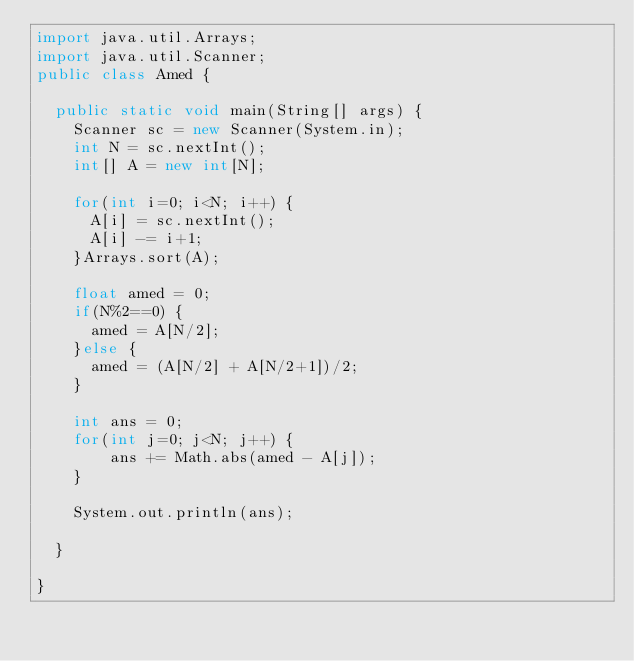<code> <loc_0><loc_0><loc_500><loc_500><_Java_>import java.util.Arrays;
import java.util.Scanner;
public class Amed {

	public static void main(String[] args) {
		Scanner sc = new Scanner(System.in);
		int N = sc.nextInt();
		int[] A = new int[N];

		for(int i=0; i<N; i++) {
			A[i] = sc.nextInt();
			A[i] -= i+1;
		}Arrays.sort(A);

		float amed = 0;
		if(N%2==0) {
			amed = A[N/2];
		}else {
			amed = (A[N/2] + A[N/2+1])/2;
		}

		int ans = 0;
		for(int j=0; j<N; j++) {
				ans += Math.abs(amed - A[j]);
		}

		System.out.println(ans);

	}

}
</code> 